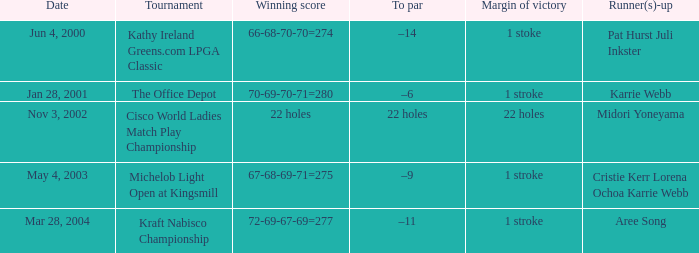Would you mind parsing the complete table? {'header': ['Date', 'Tournament', 'Winning score', 'To par', 'Margin of victory', 'Runner(s)-up'], 'rows': [['Jun 4, 2000', 'Kathy Ireland Greens.com LPGA Classic', '66-68-70-70=274', '–14', '1 stoke', 'Pat Hurst Juli Inkster'], ['Jan 28, 2001', 'The Office Depot', '70-69-70-71=280', '–6', '1 stroke', 'Karrie Webb'], ['Nov 3, 2002', 'Cisco World Ladies Match Play Championship', '22 holes', '22 holes', '22 holes', 'Midori Yoneyama'], ['May 4, 2003', 'Michelob Light Open at Kingsmill', '67-68-69-71=275', '–9', '1 stroke', 'Cristie Kerr Lorena Ochoa Karrie Webb'], ['Mar 28, 2004', 'Kraft Nabisco Championship', '72-69-67-69=277', '–11', '1 stroke', 'Aree Song']]} What date were the runner ups pat hurst juli inkster? Jun 4, 2000. 